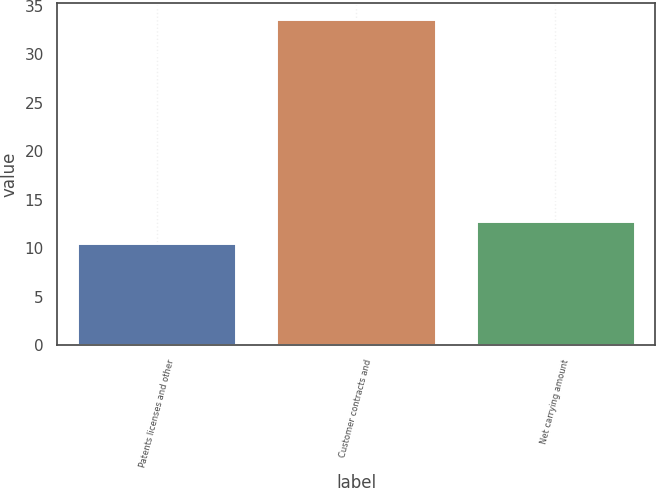<chart> <loc_0><loc_0><loc_500><loc_500><bar_chart><fcel>Patents licenses and other<fcel>Customer contracts and<fcel>Net carrying amount<nl><fcel>10.5<fcel>33.6<fcel>12.81<nl></chart> 